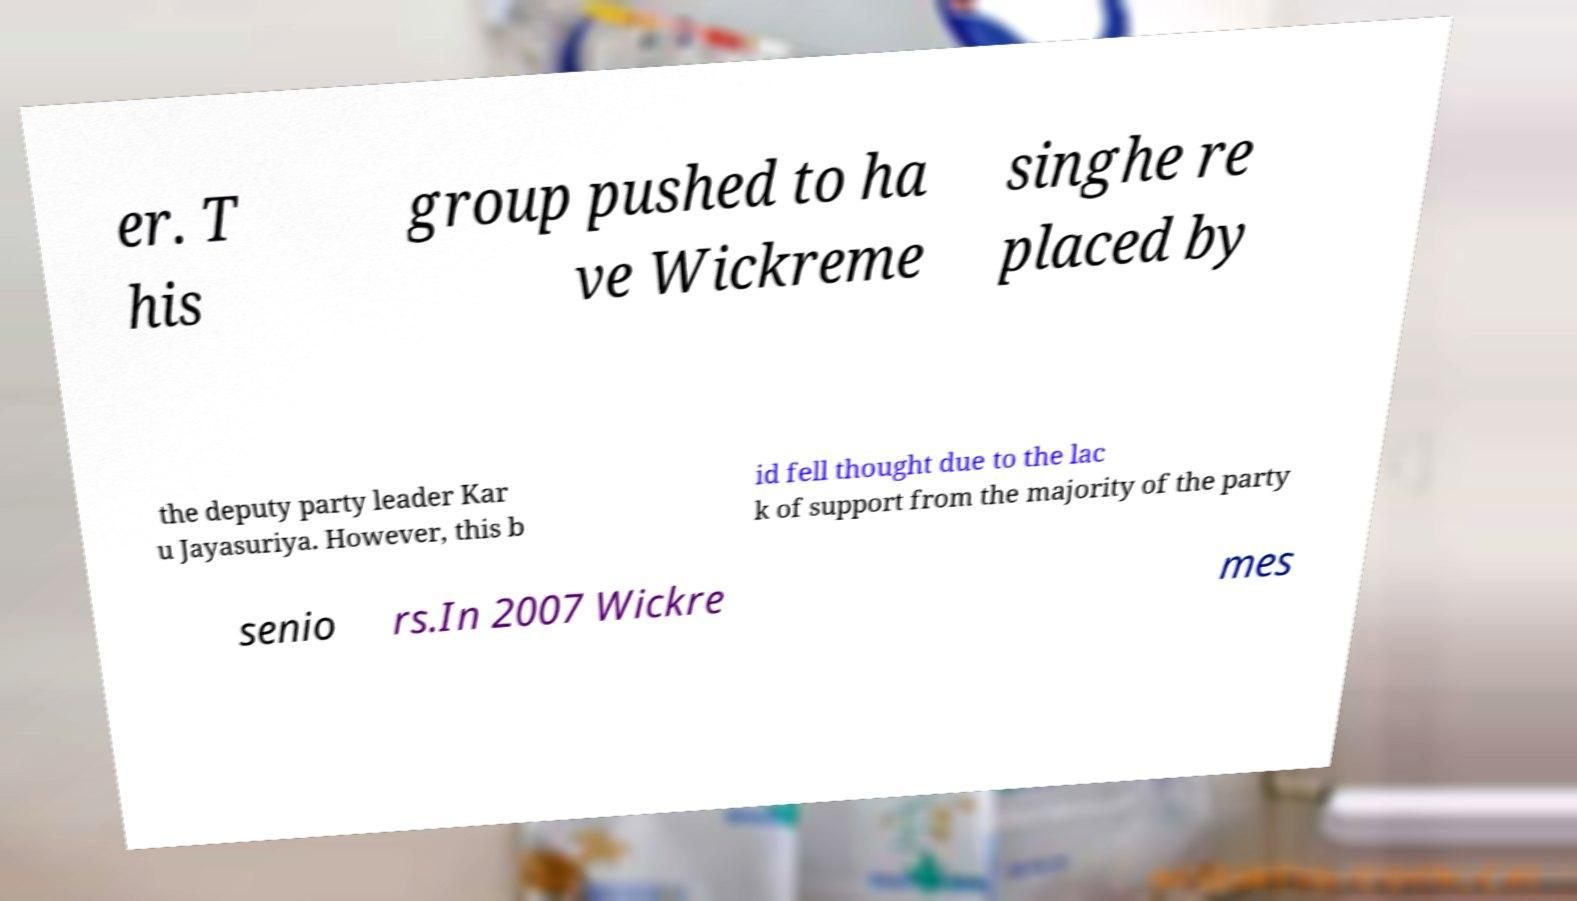What messages or text are displayed in this image? I need them in a readable, typed format. er. T his group pushed to ha ve Wickreme singhe re placed by the deputy party leader Kar u Jayasuriya. However, this b id fell thought due to the lac k of support from the majority of the party senio rs.In 2007 Wickre mes 